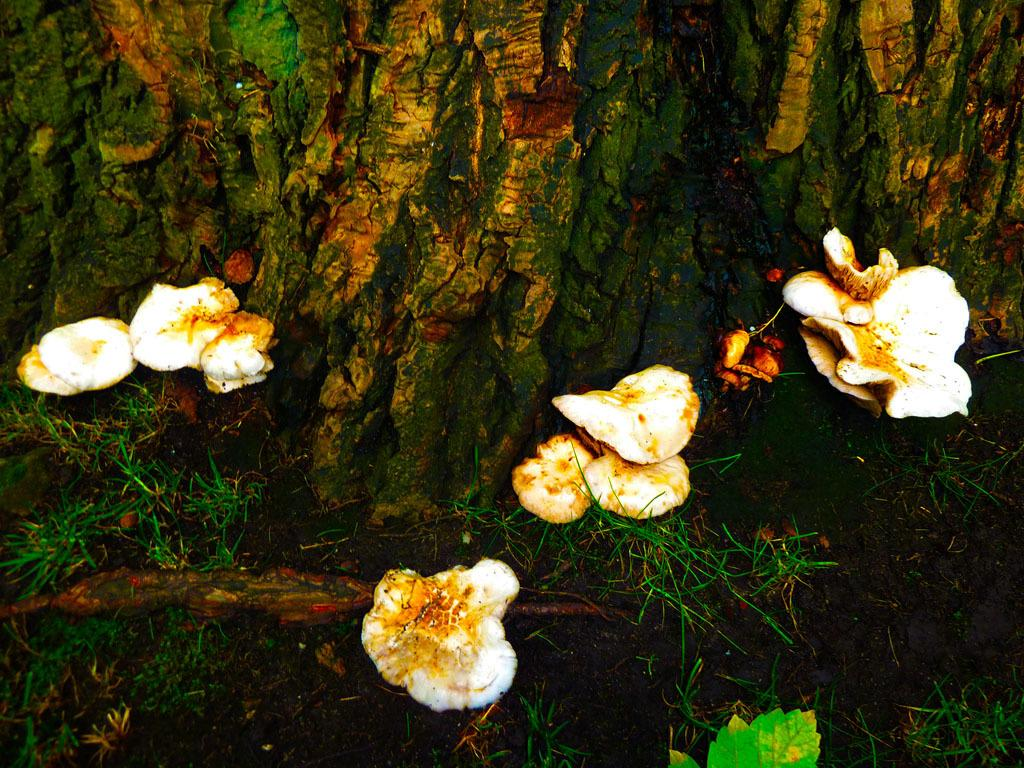What type of vegetation is growing beside the bark of the tree in the image? There are mushrooms growing beside the bark of a tree in the image. What type of ground cover can be seen in the image? There is grass visible in the image. What type of bean is hanging from the tree in the image? There is no bean present in the image; it features mushrooms growing beside the tree bark and grass. What type of skirt is visible on the tree in the image? There is no skirt present in the image; it features mushrooms growing beside the tree bark and grass. 